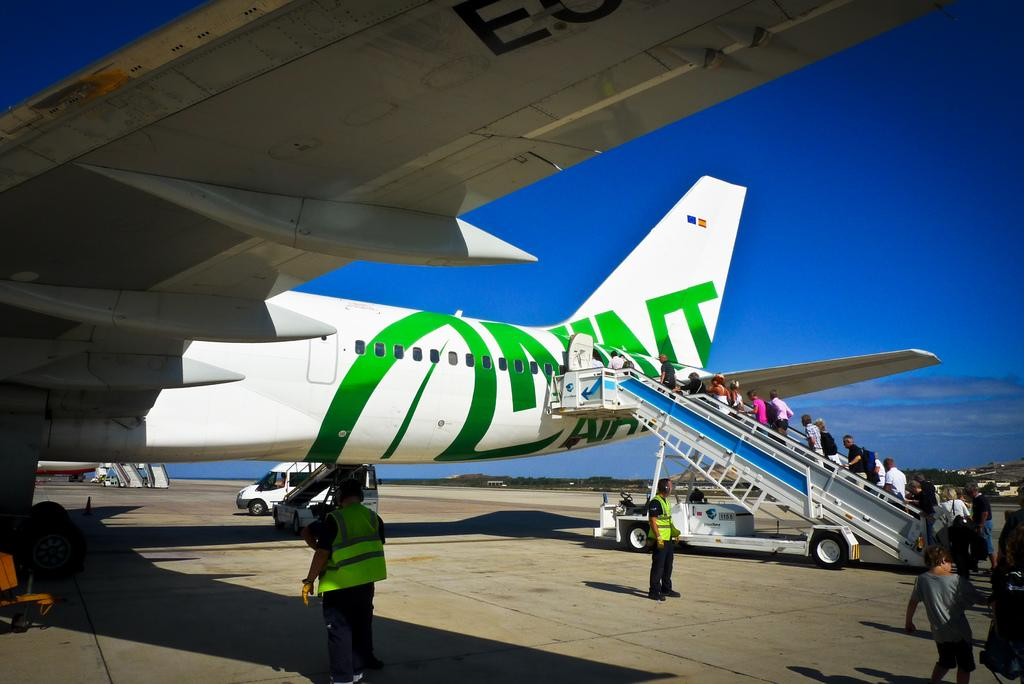<image>
Summarize the visual content of the image. a white jet with green writing loading passengers on a staircase with the numbers 1155 